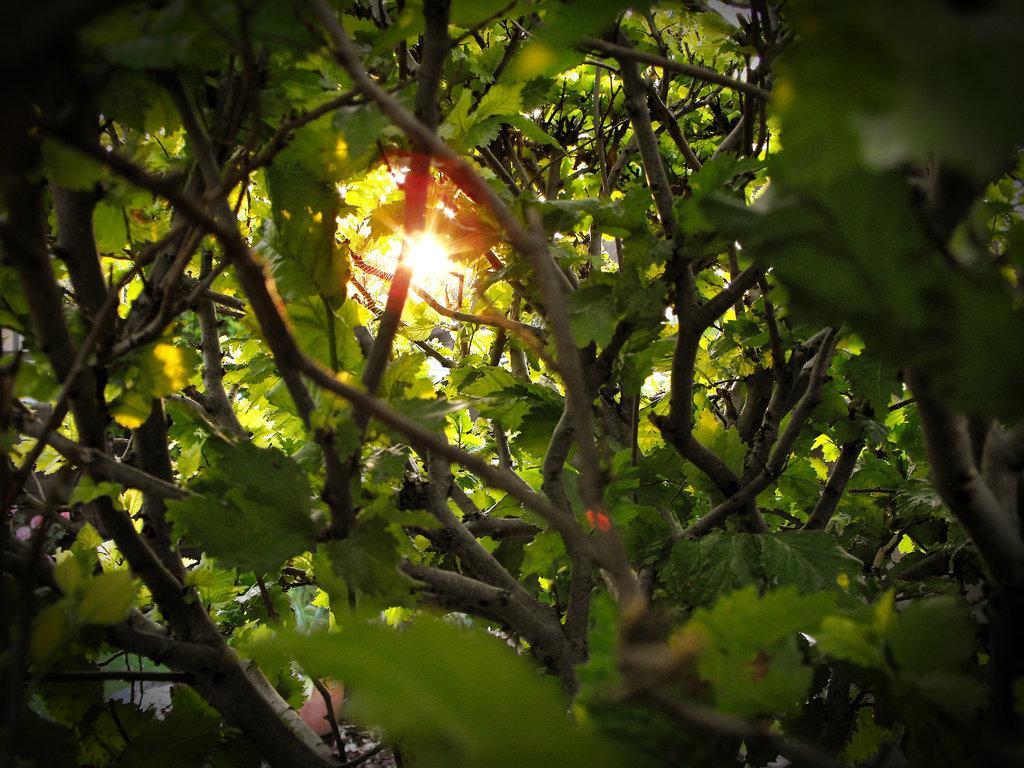Could you give a brief overview of what you see in this image? In the foreground of this picture, there are trees and in the background, there is a sun. 